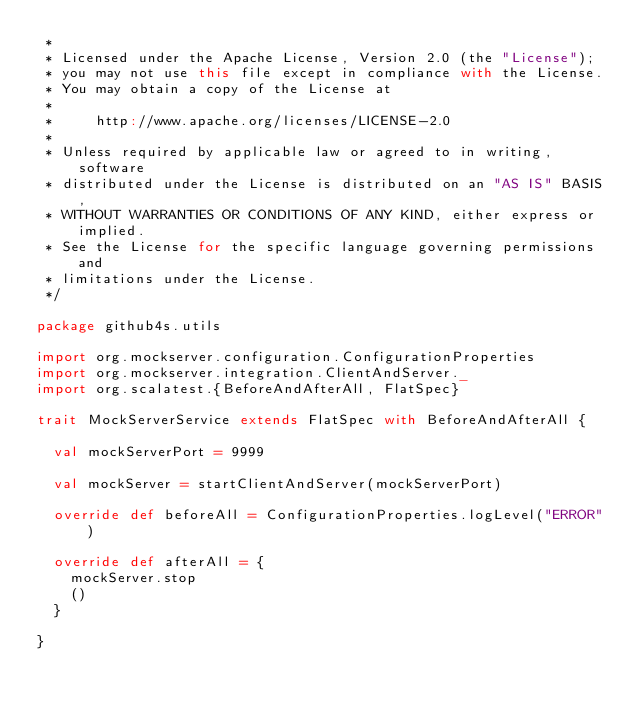Convert code to text. <code><loc_0><loc_0><loc_500><loc_500><_Scala_> *
 * Licensed under the Apache License, Version 2.0 (the "License");
 * you may not use this file except in compliance with the License.
 * You may obtain a copy of the License at
 *
 *     http://www.apache.org/licenses/LICENSE-2.0
 *
 * Unless required by applicable law or agreed to in writing, software
 * distributed under the License is distributed on an "AS IS" BASIS,
 * WITHOUT WARRANTIES OR CONDITIONS OF ANY KIND, either express or implied.
 * See the License for the specific language governing permissions and
 * limitations under the License.
 */

package github4s.utils

import org.mockserver.configuration.ConfigurationProperties
import org.mockserver.integration.ClientAndServer._
import org.scalatest.{BeforeAndAfterAll, FlatSpec}

trait MockServerService extends FlatSpec with BeforeAndAfterAll {

  val mockServerPort = 9999

  val mockServer = startClientAndServer(mockServerPort)

  override def beforeAll = ConfigurationProperties.logLevel("ERROR")

  override def afterAll = {
    mockServer.stop
    ()
  }

}
</code> 